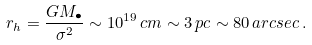<formula> <loc_0><loc_0><loc_500><loc_500>r _ { h } = \frac { G M _ { \bullet } } { \sigma ^ { 2 } } \sim 1 0 ^ { 1 9 } \, c m \sim 3 \, p c \sim 8 0 \, a r c s e c \, .</formula> 